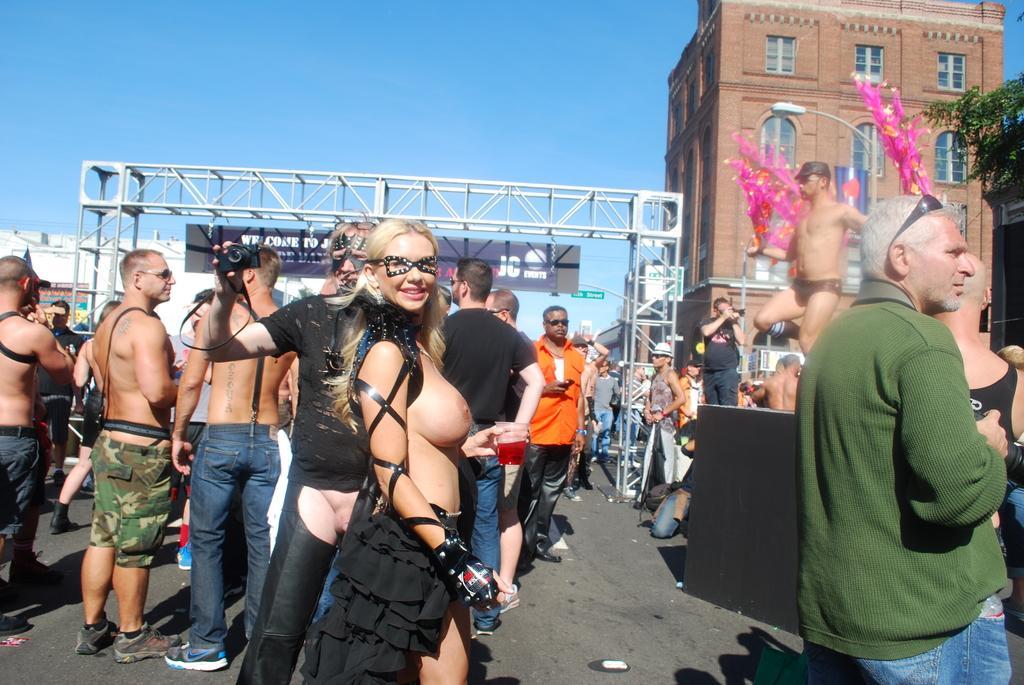In one or two sentences, can you explain what this image depicts? There are some persons standing at the bottom of this image. There is a building on the right side of this image, There is a iron object is in the middle of this image. There is a sky on the top of this image. 